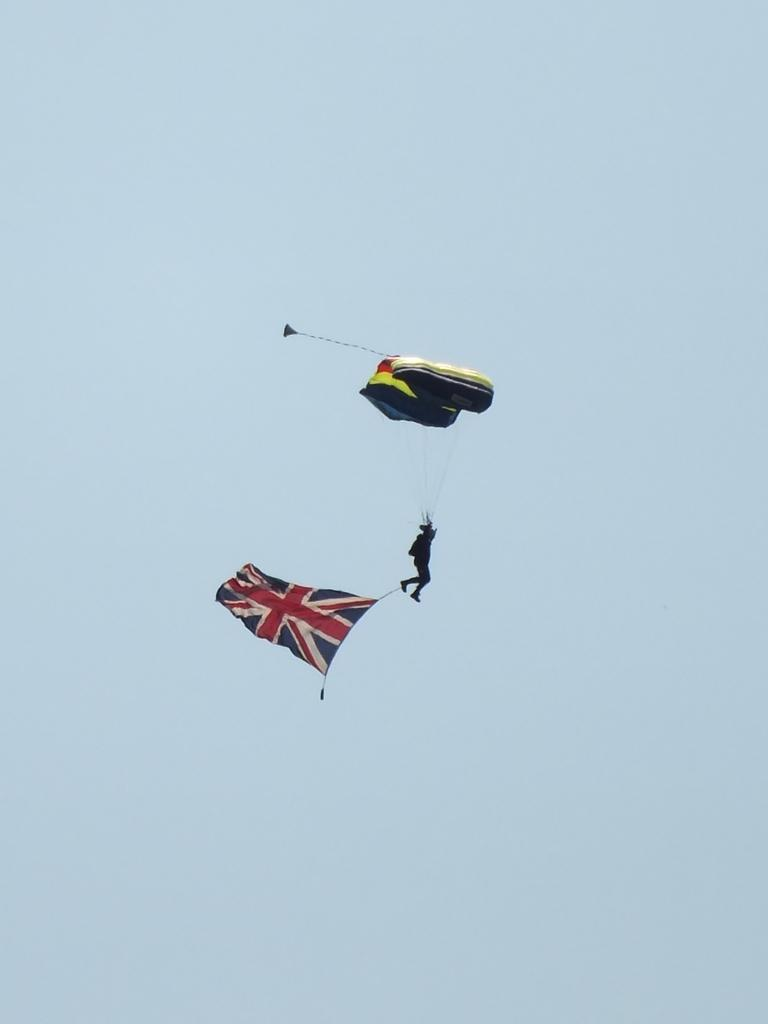What activity is the person in the image engaged in? The person is paragliding in the image. What is attached to the person's leg? The person has a flag tied to their leg with a rope. What can be seen in the background of the image? The sky is visible in the image. How would you describe the weather based on the appearance of the sky? The sky appears to be cloudy in the image. How many apples are being used as sticks to support the paraglider in the image? There are no apples or sticks present in the image; the person is paragliding using a paraglider wing. Can you see any rabbits in the image? There are no rabbits visible in the image. 